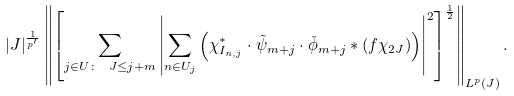Convert formula to latex. <formula><loc_0><loc_0><loc_500><loc_500>| J | ^ { \frac { 1 } { p ^ { \prime } } } \left \| \left [ \sum _ { j \in U \colon \ J \leq j + m } \left | \sum _ { n \in U _ { j } } \left ( \chi ^ { * } _ { I _ { n , j } } \cdot \tilde { \psi } _ { m + j } \cdot \check { \phi } _ { m + j } \ast ( f \chi _ { 2 J } ) \right ) \right | ^ { 2 } \right ] ^ { \frac { 1 } { 2 } } \right \| _ { L ^ { p } ( J ) } .</formula> 